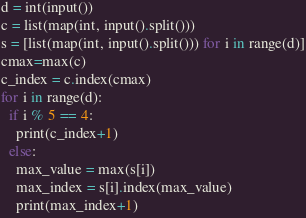<code> <loc_0><loc_0><loc_500><loc_500><_Python_>d = int(input())
c = list(map(int, input().split()))
s = [list(map(int, input().split())) for i in range(d)]
cmax=max(c)
c_index = c.index(cmax)
for i in range(d):
  if i % 5 == 4:
    print(c_index+1)
  else:
    max_value = max(s[i])
    max_index = s[i].index(max_value)
    print(max_index+1)
</code> 